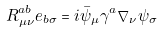<formula> <loc_0><loc_0><loc_500><loc_500>R _ { \mu \nu } ^ { a b } e _ { b \sigma } = i \bar { \psi } _ { \mu } \gamma ^ { a } \nabla _ { \nu } \psi _ { \sigma }</formula> 